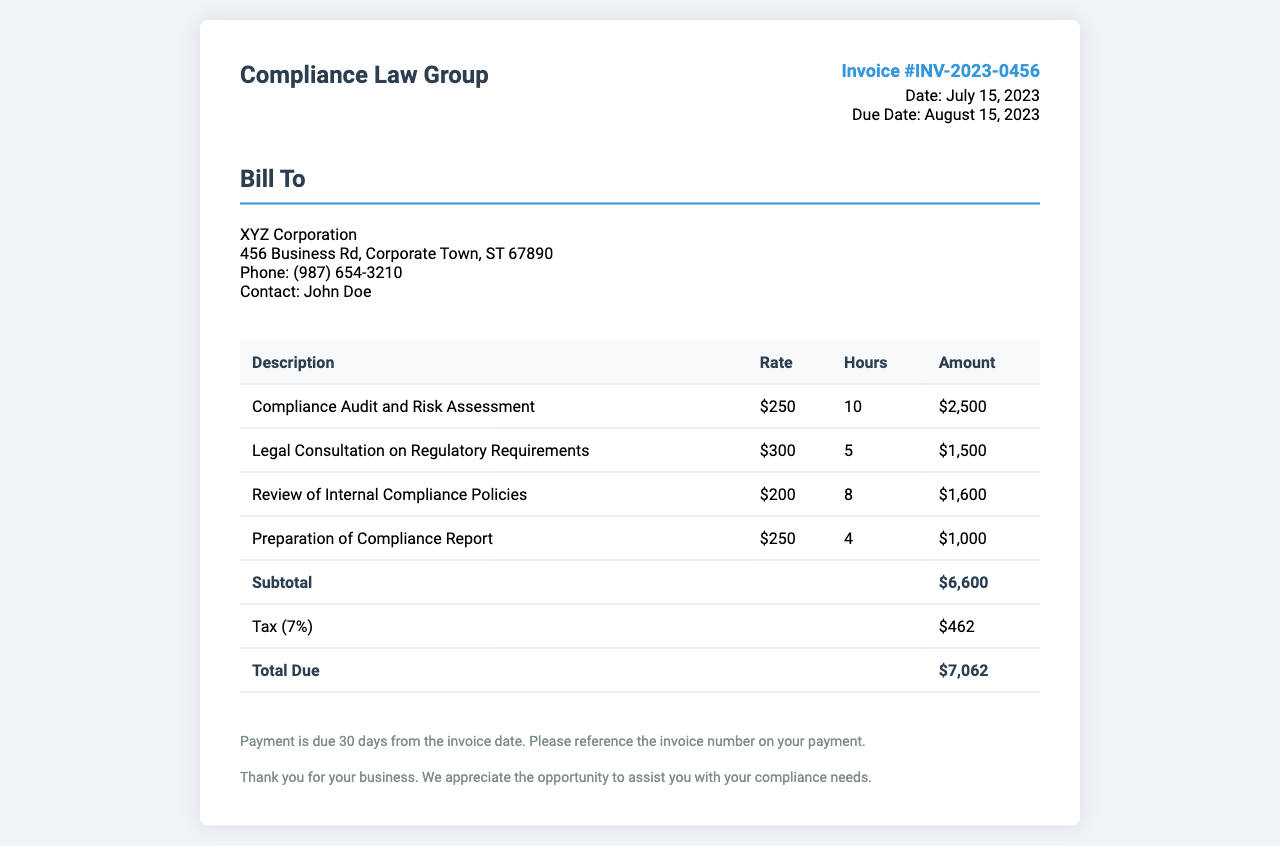What is the invoice number? The invoice number is located in the upper right corner of the document, indicating the specific invoice issued.
Answer: INV-2023-0456 What is the date of the invoice? The date of the invoice is mentioned alongside the invoice number, indicating when it was issued.
Answer: July 15, 2023 Who is the contact person for the client? The contact person is listed in the client details section of the document, providing a point of contact for the client.
Answer: John Doe What is the total amount due? The total amount due is calculated as the subtotal plus tax, located at the bottom of the invoice.
Answer: $7,062 How many hours were worked for the Compliance Audit and Risk Assessment? The hours worked for this service are specified in the hourly breakdown table of the document.
Answer: 10 What percentage is the tax applied to the subtotal? The tax percentage is indicated in the invoice, reflecting the additional cost added to the subtotal.
Answer: 7% What is the hourly rate for Legal Consultation on Regulatory Requirements? The hourly rate for this specific service is listed in the breakdown table of the invoice, showing the cost for the legal consultation.
Answer: $300 What was the subtotal amount before tax? The subtotal amount is provided in the invoice as the sum of all services rendered before tax is added.
Answer: $6,600 When is the payment due? The payment due date is indicated in the terms section of the document, specifying the timeframe for payment.
Answer: August 15, 2023 